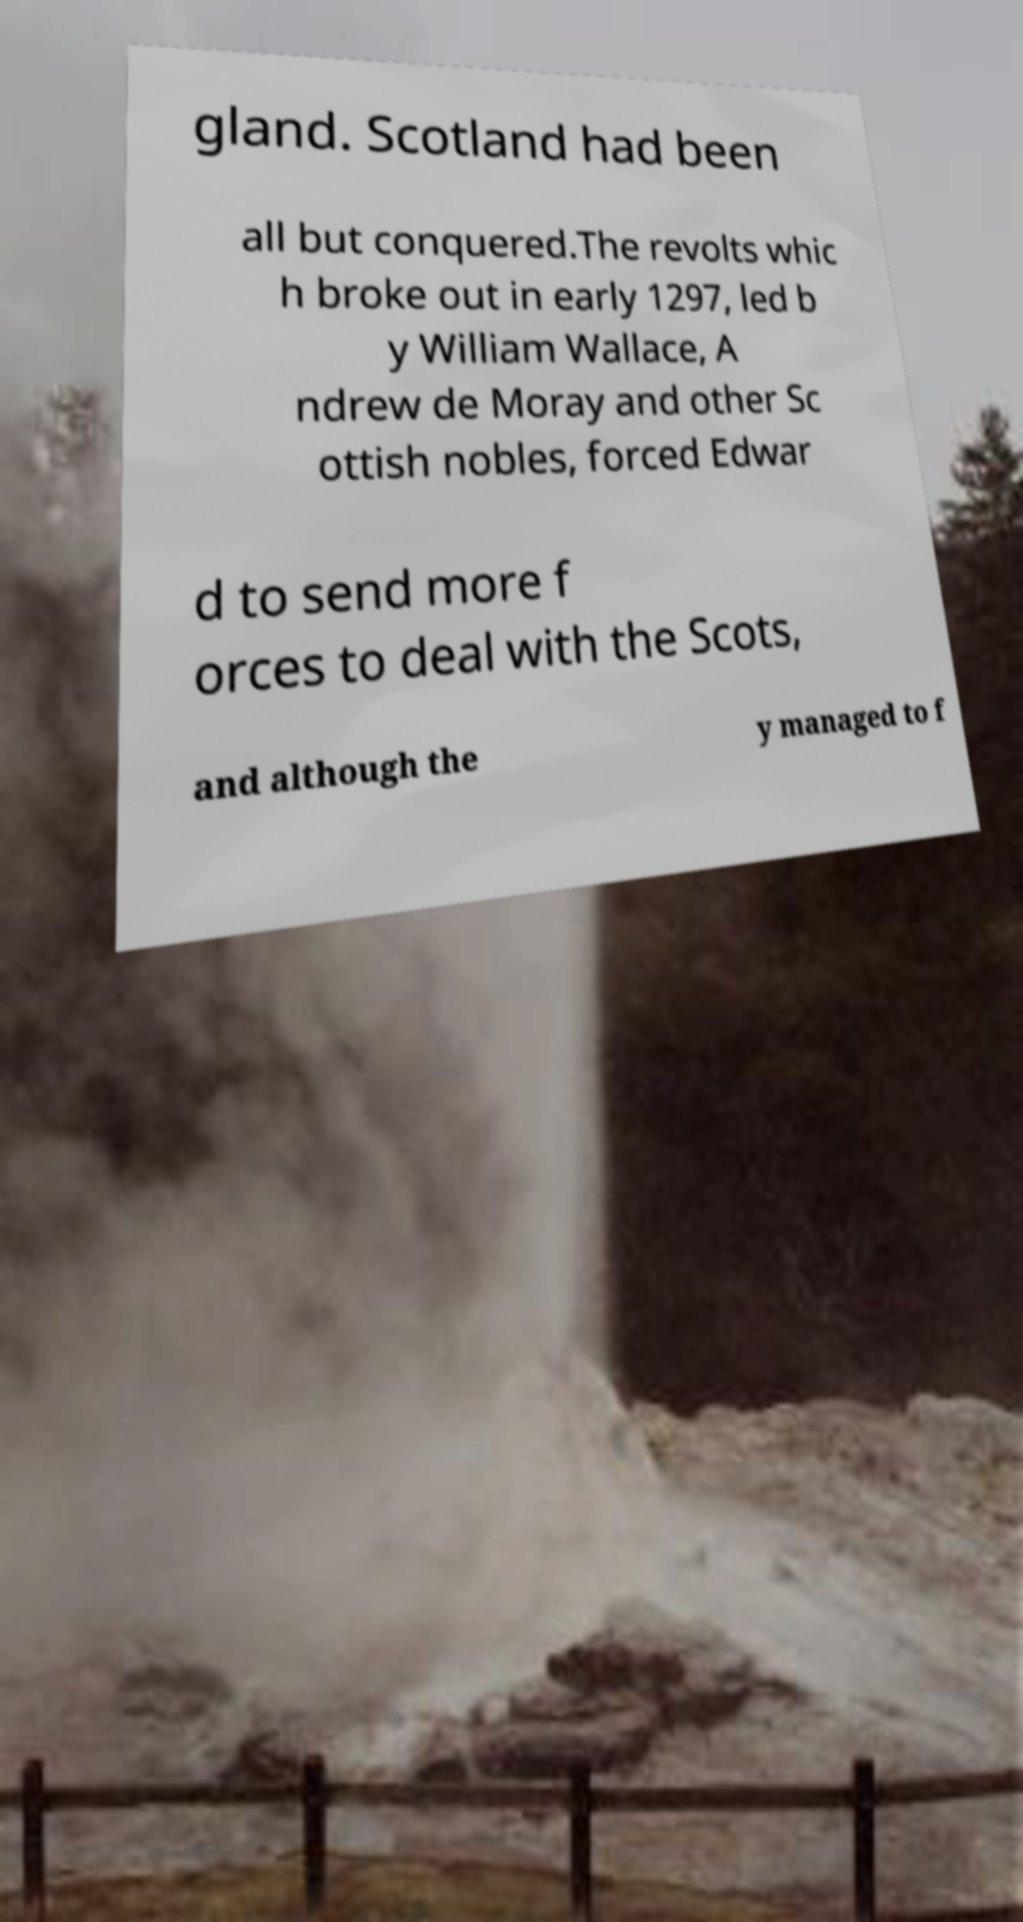Can you read and provide the text displayed in the image?This photo seems to have some interesting text. Can you extract and type it out for me? gland. Scotland had been all but conquered.The revolts whic h broke out in early 1297, led b y William Wallace, A ndrew de Moray and other Sc ottish nobles, forced Edwar d to send more f orces to deal with the Scots, and although the y managed to f 